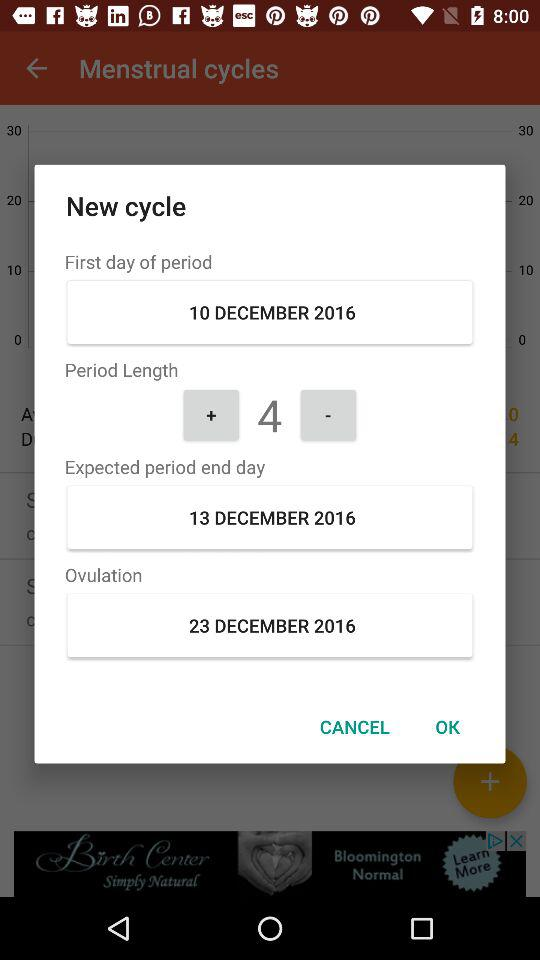How many days are between the first day of my period and the expected period end day?
Answer the question using a single word or phrase. 3 